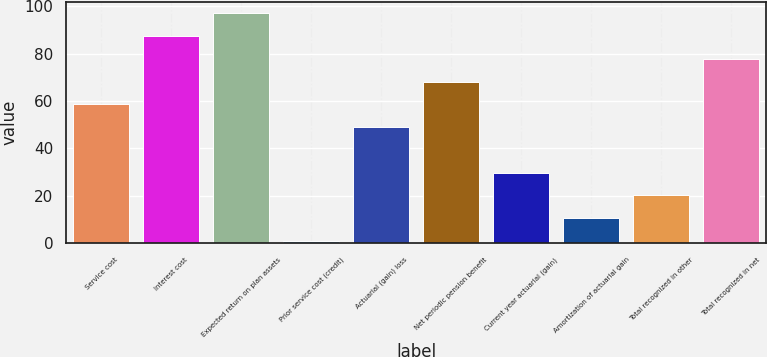Convert chart to OTSL. <chart><loc_0><loc_0><loc_500><loc_500><bar_chart><fcel>Service cost<fcel>Interest cost<fcel>Expected return on plan assets<fcel>Prior service cost (credit)<fcel>Actuarial (gain) loss<fcel>Net periodic pension benefit<fcel>Current year actuarial (gain)<fcel>Amortization of actuarial gain<fcel>Total recognized in other<fcel>Total recognized in net<nl><fcel>58.6<fcel>87.4<fcel>97<fcel>1<fcel>49<fcel>68.2<fcel>29.8<fcel>10.6<fcel>20.2<fcel>77.8<nl></chart> 